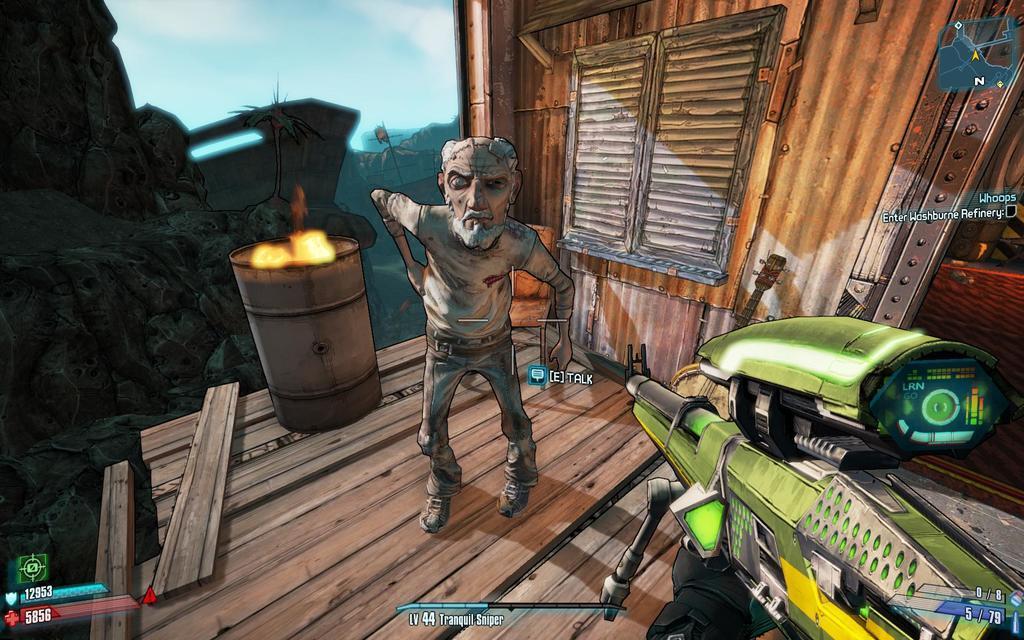Can you describe this image briefly? This is an animation picture. In this image we can see a person, barrel. Also there is a building with window. 